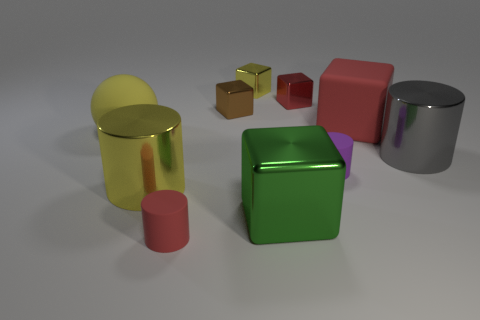There is a yellow shiny object that is in front of the purple object right of the large ball; what is its size?
Offer a very short reply. Large. Are the big yellow thing that is behind the small purple matte thing and the large cube in front of the large yellow matte object made of the same material?
Your response must be concise. No. There is a small matte cylinder that is in front of the green shiny cube; is its color the same as the matte cube?
Your answer should be very brief. Yes. What number of small yellow objects are behind the small red matte cylinder?
Your answer should be very brief. 1. Is the material of the big yellow sphere the same as the cylinder that is to the right of the big red rubber block?
Make the answer very short. No. What size is the red thing that is made of the same material as the yellow block?
Provide a short and direct response. Small. Is the number of big green shiny objects that are in front of the yellow cube greater than the number of large blocks that are to the right of the large green thing?
Keep it short and to the point. No. Is there a small yellow metallic object of the same shape as the big red rubber thing?
Offer a terse response. Yes. Is the size of the block that is in front of the gray shiny object the same as the small purple rubber object?
Offer a very short reply. No. Are any small red metal cubes visible?
Keep it short and to the point. Yes. 